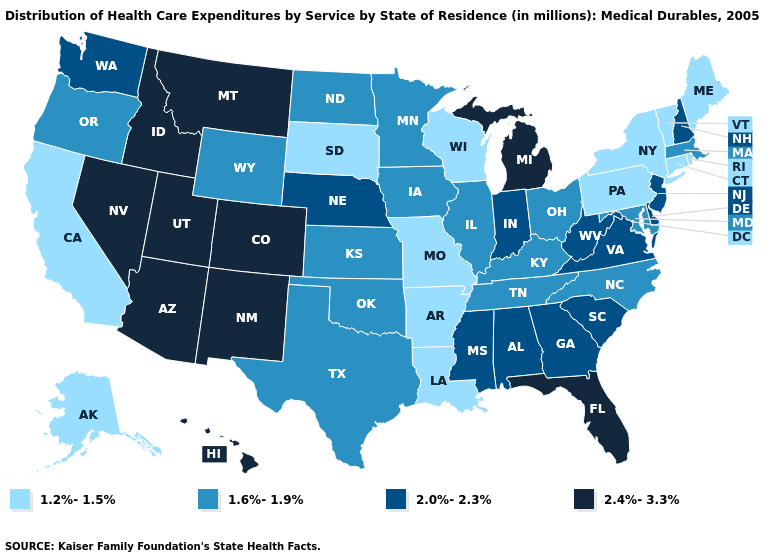Name the states that have a value in the range 1.6%-1.9%?
Short answer required. Illinois, Iowa, Kansas, Kentucky, Maryland, Massachusetts, Minnesota, North Carolina, North Dakota, Ohio, Oklahoma, Oregon, Tennessee, Texas, Wyoming. Among the states that border Wyoming , does South Dakota have the lowest value?
Give a very brief answer. Yes. What is the value of South Carolina?
Answer briefly. 2.0%-2.3%. What is the highest value in the MidWest ?
Quick response, please. 2.4%-3.3%. Name the states that have a value in the range 1.6%-1.9%?
Write a very short answer. Illinois, Iowa, Kansas, Kentucky, Maryland, Massachusetts, Minnesota, North Carolina, North Dakota, Ohio, Oklahoma, Oregon, Tennessee, Texas, Wyoming. Which states have the lowest value in the USA?
Quick response, please. Alaska, Arkansas, California, Connecticut, Louisiana, Maine, Missouri, New York, Pennsylvania, Rhode Island, South Dakota, Vermont, Wisconsin. Does Idaho have a lower value than Montana?
Write a very short answer. No. Does the map have missing data?
Be succinct. No. What is the value of New Jersey?
Write a very short answer. 2.0%-2.3%. Among the states that border New Jersey , does New York have the highest value?
Give a very brief answer. No. What is the value of Alaska?
Short answer required. 1.2%-1.5%. What is the value of South Carolina?
Short answer required. 2.0%-2.3%. Does Hawaii have the highest value in the USA?
Give a very brief answer. Yes. What is the value of Mississippi?
Give a very brief answer. 2.0%-2.3%. Does Massachusetts have the highest value in the USA?
Answer briefly. No. 